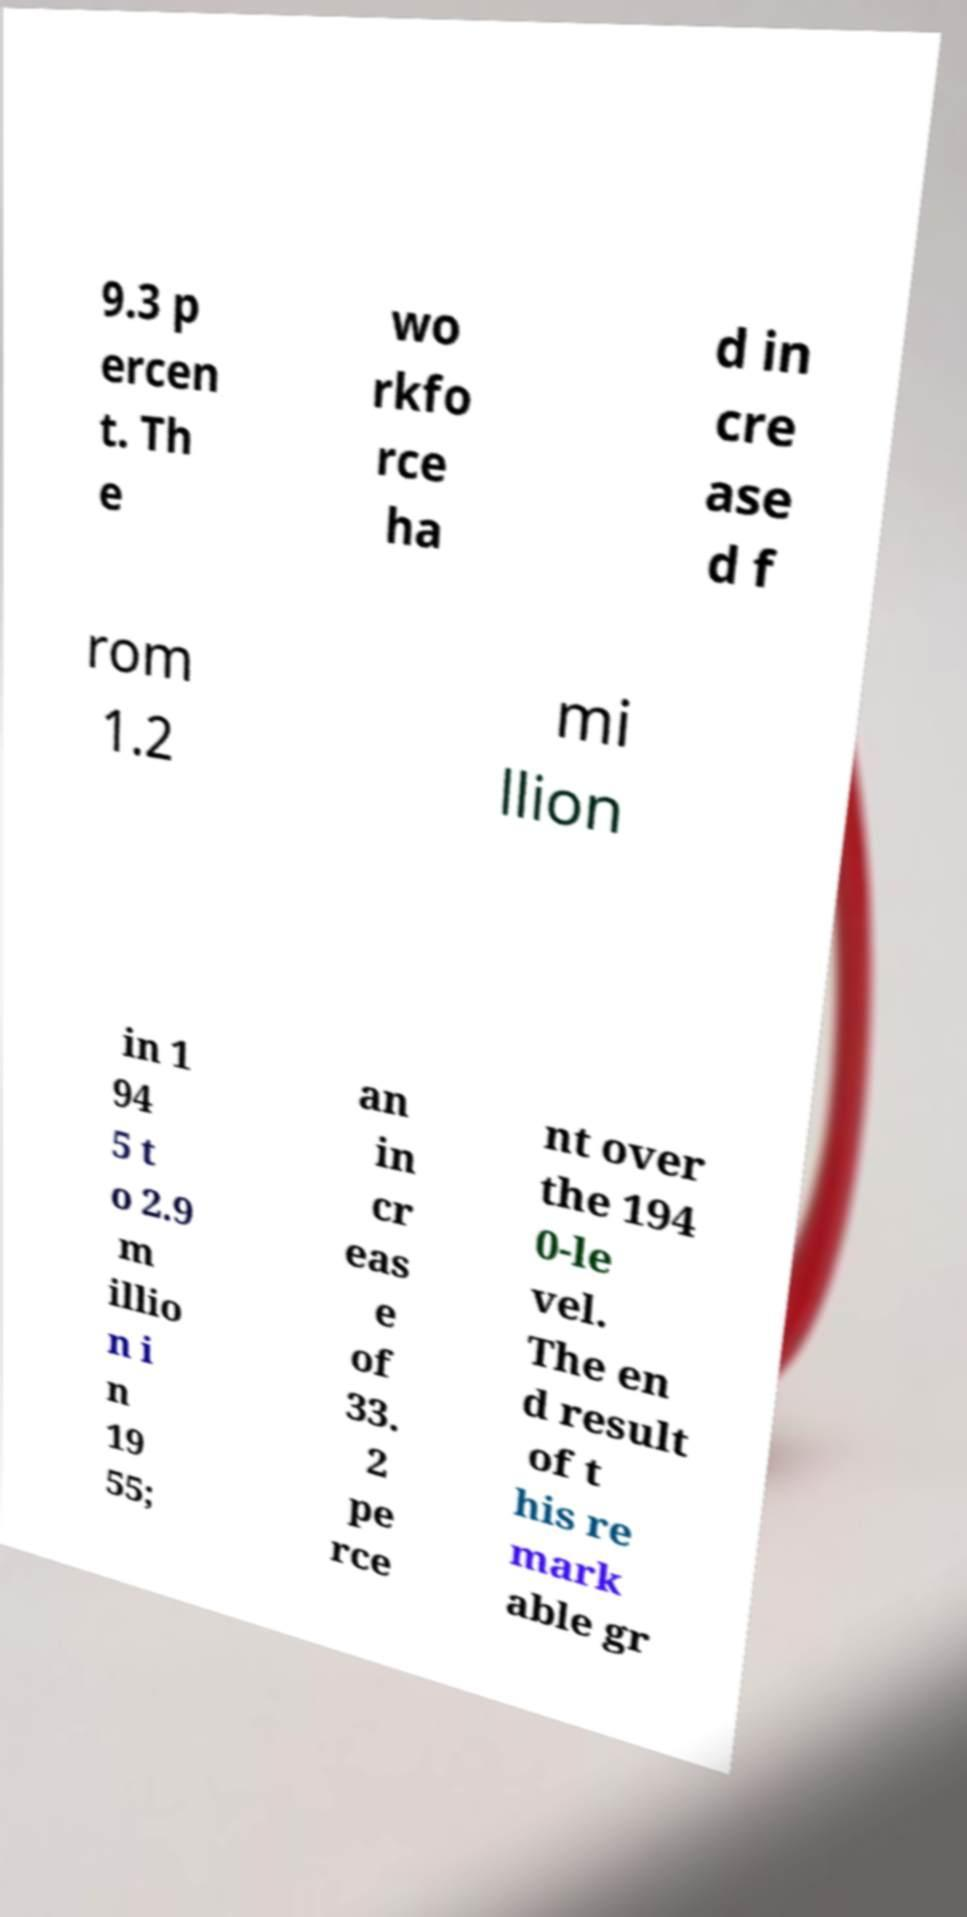Please read and relay the text visible in this image. What does it say? 9.3 p ercen t. Th e wo rkfo rce ha d in cre ase d f rom 1.2 mi llion in 1 94 5 t o 2.9 m illio n i n 19 55; an in cr eas e of 33. 2 pe rce nt over the 194 0-le vel. The en d result of t his re mark able gr 